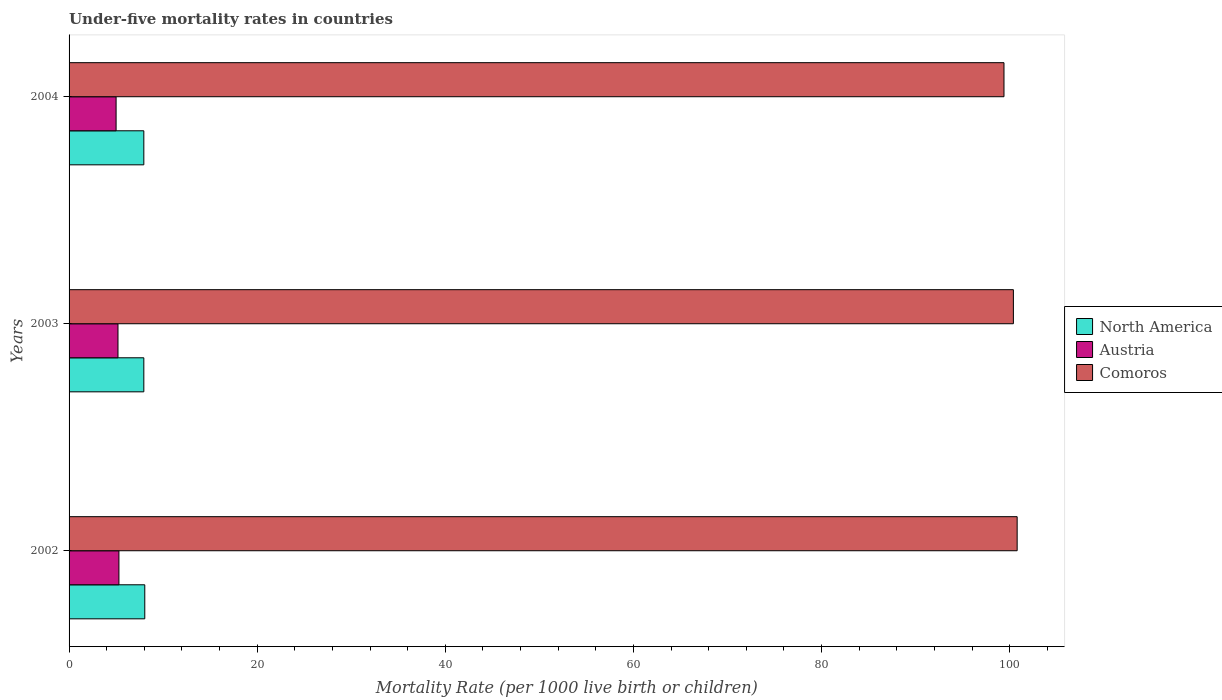Are the number of bars on each tick of the Y-axis equal?
Keep it short and to the point. Yes. How many bars are there on the 3rd tick from the top?
Offer a terse response. 3. How many bars are there on the 3rd tick from the bottom?
Make the answer very short. 3. What is the label of the 3rd group of bars from the top?
Provide a short and direct response. 2002. In how many cases, is the number of bars for a given year not equal to the number of legend labels?
Make the answer very short. 0. What is the under-five mortality rate in North America in 2002?
Your response must be concise. 8.05. Across all years, what is the maximum under-five mortality rate in North America?
Ensure brevity in your answer.  8.05. Across all years, what is the minimum under-five mortality rate in Comoros?
Offer a terse response. 99.4. In which year was the under-five mortality rate in Comoros maximum?
Your response must be concise. 2002. In which year was the under-five mortality rate in Austria minimum?
Offer a very short reply. 2004. What is the total under-five mortality rate in North America in the graph?
Offer a terse response. 23.95. What is the difference between the under-five mortality rate in North America in 2002 and that in 2003?
Your answer should be compact. 0.1. What is the difference between the under-five mortality rate in North America in 2003 and the under-five mortality rate in Austria in 2002?
Your response must be concise. 2.65. What is the average under-five mortality rate in Comoros per year?
Offer a very short reply. 100.2. In the year 2004, what is the difference between the under-five mortality rate in North America and under-five mortality rate in Austria?
Keep it short and to the point. 2.95. What is the ratio of the under-five mortality rate in Comoros in 2003 to that in 2004?
Your answer should be very brief. 1.01. Is the under-five mortality rate in North America in 2002 less than that in 2004?
Your response must be concise. No. What is the difference between the highest and the second highest under-five mortality rate in North America?
Keep it short and to the point. 0.1. What is the difference between the highest and the lowest under-five mortality rate in North America?
Keep it short and to the point. 0.1. In how many years, is the under-five mortality rate in Austria greater than the average under-five mortality rate in Austria taken over all years?
Keep it short and to the point. 2. What does the 3rd bar from the top in 2004 represents?
Your answer should be compact. North America. What does the 2nd bar from the bottom in 2003 represents?
Keep it short and to the point. Austria. Is it the case that in every year, the sum of the under-five mortality rate in Comoros and under-five mortality rate in Austria is greater than the under-five mortality rate in North America?
Provide a succinct answer. Yes. How many bars are there?
Give a very brief answer. 9. Are all the bars in the graph horizontal?
Offer a terse response. Yes. Does the graph contain any zero values?
Provide a short and direct response. No. Where does the legend appear in the graph?
Ensure brevity in your answer.  Center right. What is the title of the graph?
Offer a very short reply. Under-five mortality rates in countries. Does "Austria" appear as one of the legend labels in the graph?
Provide a short and direct response. Yes. What is the label or title of the X-axis?
Keep it short and to the point. Mortality Rate (per 1000 live birth or children). What is the label or title of the Y-axis?
Your answer should be compact. Years. What is the Mortality Rate (per 1000 live birth or children) of North America in 2002?
Ensure brevity in your answer.  8.05. What is the Mortality Rate (per 1000 live birth or children) in Comoros in 2002?
Your answer should be very brief. 100.8. What is the Mortality Rate (per 1000 live birth or children) in North America in 2003?
Provide a short and direct response. 7.95. What is the Mortality Rate (per 1000 live birth or children) of Austria in 2003?
Provide a succinct answer. 5.2. What is the Mortality Rate (per 1000 live birth or children) of Comoros in 2003?
Keep it short and to the point. 100.4. What is the Mortality Rate (per 1000 live birth or children) of North America in 2004?
Make the answer very short. 7.95. What is the Mortality Rate (per 1000 live birth or children) of Comoros in 2004?
Offer a terse response. 99.4. Across all years, what is the maximum Mortality Rate (per 1000 live birth or children) in North America?
Make the answer very short. 8.05. Across all years, what is the maximum Mortality Rate (per 1000 live birth or children) in Austria?
Give a very brief answer. 5.3. Across all years, what is the maximum Mortality Rate (per 1000 live birth or children) in Comoros?
Ensure brevity in your answer.  100.8. Across all years, what is the minimum Mortality Rate (per 1000 live birth or children) in North America?
Provide a short and direct response. 7.95. Across all years, what is the minimum Mortality Rate (per 1000 live birth or children) in Austria?
Provide a short and direct response. 5. Across all years, what is the minimum Mortality Rate (per 1000 live birth or children) in Comoros?
Offer a very short reply. 99.4. What is the total Mortality Rate (per 1000 live birth or children) of North America in the graph?
Offer a terse response. 23.95. What is the total Mortality Rate (per 1000 live birth or children) in Austria in the graph?
Your answer should be compact. 15.5. What is the total Mortality Rate (per 1000 live birth or children) in Comoros in the graph?
Offer a terse response. 300.6. What is the difference between the Mortality Rate (per 1000 live birth or children) in North America in 2002 and that in 2003?
Keep it short and to the point. 0.1. What is the difference between the Mortality Rate (per 1000 live birth or children) in Austria in 2002 and that in 2003?
Your response must be concise. 0.1. What is the difference between the Mortality Rate (per 1000 live birth or children) in North America in 2002 and that in 2004?
Give a very brief answer. 0.1. What is the difference between the Mortality Rate (per 1000 live birth or children) in Comoros in 2002 and that in 2004?
Provide a short and direct response. 1.4. What is the difference between the Mortality Rate (per 1000 live birth or children) in North America in 2003 and that in 2004?
Ensure brevity in your answer.  0. What is the difference between the Mortality Rate (per 1000 live birth or children) in Austria in 2003 and that in 2004?
Give a very brief answer. 0.2. What is the difference between the Mortality Rate (per 1000 live birth or children) of Comoros in 2003 and that in 2004?
Provide a succinct answer. 1. What is the difference between the Mortality Rate (per 1000 live birth or children) of North America in 2002 and the Mortality Rate (per 1000 live birth or children) of Austria in 2003?
Your answer should be compact. 2.85. What is the difference between the Mortality Rate (per 1000 live birth or children) in North America in 2002 and the Mortality Rate (per 1000 live birth or children) in Comoros in 2003?
Keep it short and to the point. -92.35. What is the difference between the Mortality Rate (per 1000 live birth or children) of Austria in 2002 and the Mortality Rate (per 1000 live birth or children) of Comoros in 2003?
Your answer should be very brief. -95.1. What is the difference between the Mortality Rate (per 1000 live birth or children) of North America in 2002 and the Mortality Rate (per 1000 live birth or children) of Austria in 2004?
Ensure brevity in your answer.  3.05. What is the difference between the Mortality Rate (per 1000 live birth or children) in North America in 2002 and the Mortality Rate (per 1000 live birth or children) in Comoros in 2004?
Offer a very short reply. -91.35. What is the difference between the Mortality Rate (per 1000 live birth or children) in Austria in 2002 and the Mortality Rate (per 1000 live birth or children) in Comoros in 2004?
Offer a very short reply. -94.1. What is the difference between the Mortality Rate (per 1000 live birth or children) of North America in 2003 and the Mortality Rate (per 1000 live birth or children) of Austria in 2004?
Provide a succinct answer. 2.95. What is the difference between the Mortality Rate (per 1000 live birth or children) of North America in 2003 and the Mortality Rate (per 1000 live birth or children) of Comoros in 2004?
Provide a short and direct response. -91.45. What is the difference between the Mortality Rate (per 1000 live birth or children) of Austria in 2003 and the Mortality Rate (per 1000 live birth or children) of Comoros in 2004?
Ensure brevity in your answer.  -94.2. What is the average Mortality Rate (per 1000 live birth or children) in North America per year?
Make the answer very short. 7.98. What is the average Mortality Rate (per 1000 live birth or children) in Austria per year?
Provide a short and direct response. 5.17. What is the average Mortality Rate (per 1000 live birth or children) of Comoros per year?
Offer a terse response. 100.2. In the year 2002, what is the difference between the Mortality Rate (per 1000 live birth or children) of North America and Mortality Rate (per 1000 live birth or children) of Austria?
Make the answer very short. 2.75. In the year 2002, what is the difference between the Mortality Rate (per 1000 live birth or children) of North America and Mortality Rate (per 1000 live birth or children) of Comoros?
Offer a terse response. -92.75. In the year 2002, what is the difference between the Mortality Rate (per 1000 live birth or children) of Austria and Mortality Rate (per 1000 live birth or children) of Comoros?
Your answer should be compact. -95.5. In the year 2003, what is the difference between the Mortality Rate (per 1000 live birth or children) of North America and Mortality Rate (per 1000 live birth or children) of Austria?
Make the answer very short. 2.75. In the year 2003, what is the difference between the Mortality Rate (per 1000 live birth or children) of North America and Mortality Rate (per 1000 live birth or children) of Comoros?
Offer a terse response. -92.45. In the year 2003, what is the difference between the Mortality Rate (per 1000 live birth or children) of Austria and Mortality Rate (per 1000 live birth or children) of Comoros?
Give a very brief answer. -95.2. In the year 2004, what is the difference between the Mortality Rate (per 1000 live birth or children) of North America and Mortality Rate (per 1000 live birth or children) of Austria?
Make the answer very short. 2.95. In the year 2004, what is the difference between the Mortality Rate (per 1000 live birth or children) of North America and Mortality Rate (per 1000 live birth or children) of Comoros?
Ensure brevity in your answer.  -91.45. In the year 2004, what is the difference between the Mortality Rate (per 1000 live birth or children) of Austria and Mortality Rate (per 1000 live birth or children) of Comoros?
Ensure brevity in your answer.  -94.4. What is the ratio of the Mortality Rate (per 1000 live birth or children) of North America in 2002 to that in 2003?
Your response must be concise. 1.01. What is the ratio of the Mortality Rate (per 1000 live birth or children) in Austria in 2002 to that in 2003?
Provide a short and direct response. 1.02. What is the ratio of the Mortality Rate (per 1000 live birth or children) of Comoros in 2002 to that in 2003?
Offer a very short reply. 1. What is the ratio of the Mortality Rate (per 1000 live birth or children) of North America in 2002 to that in 2004?
Ensure brevity in your answer.  1.01. What is the ratio of the Mortality Rate (per 1000 live birth or children) of Austria in 2002 to that in 2004?
Offer a very short reply. 1.06. What is the ratio of the Mortality Rate (per 1000 live birth or children) in Comoros in 2002 to that in 2004?
Your response must be concise. 1.01. What is the difference between the highest and the second highest Mortality Rate (per 1000 live birth or children) in North America?
Keep it short and to the point. 0.1. What is the difference between the highest and the second highest Mortality Rate (per 1000 live birth or children) of Comoros?
Give a very brief answer. 0.4. What is the difference between the highest and the lowest Mortality Rate (per 1000 live birth or children) in North America?
Provide a short and direct response. 0.1. What is the difference between the highest and the lowest Mortality Rate (per 1000 live birth or children) in Austria?
Your answer should be very brief. 0.3. 